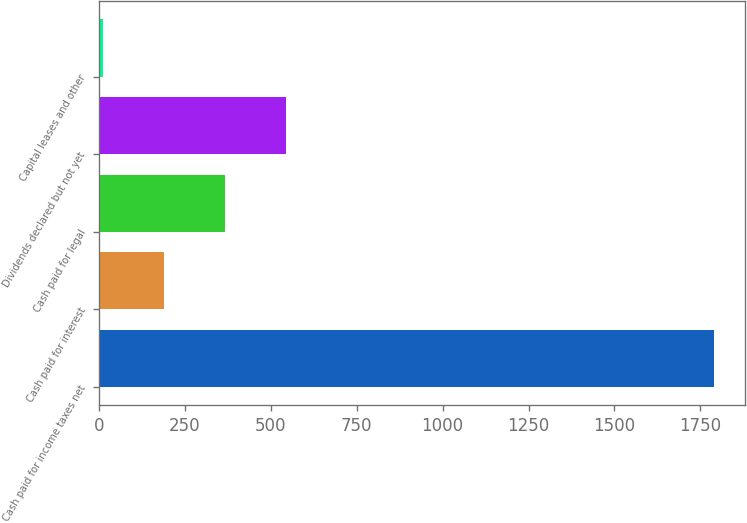Convert chart to OTSL. <chart><loc_0><loc_0><loc_500><loc_500><bar_chart><fcel>Cash paid for income taxes net<fcel>Cash paid for interest<fcel>Cash paid for legal<fcel>Dividends declared but not yet<fcel>Capital leases and other<nl><fcel>1790<fcel>188<fcel>366<fcel>544<fcel>10<nl></chart> 